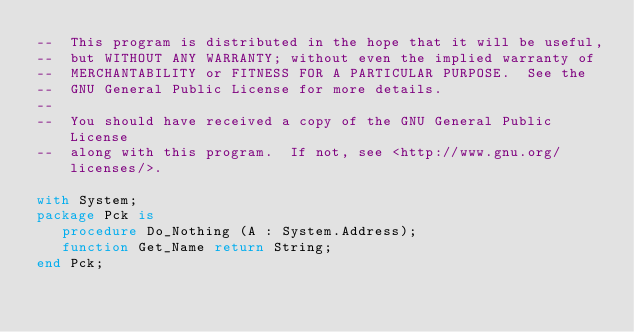Convert code to text. <code><loc_0><loc_0><loc_500><loc_500><_Ada_>--  This program is distributed in the hope that it will be useful,
--  but WITHOUT ANY WARRANTY; without even the implied warranty of
--  MERCHANTABILITY or FITNESS FOR A PARTICULAR PURPOSE.  See the
--  GNU General Public License for more details.
--
--  You should have received a copy of the GNU General Public License
--  along with this program.  If not, see <http://www.gnu.org/licenses/>.

with System;
package Pck is
   procedure Do_Nothing (A : System.Address);
   function Get_Name return String;
end Pck;
</code> 